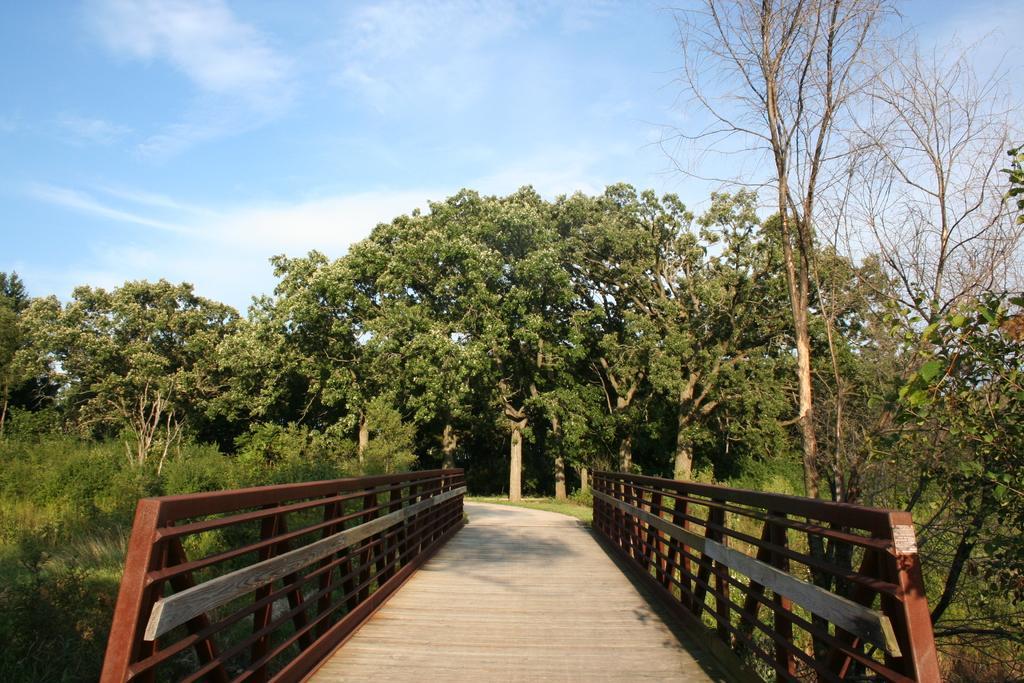Can you describe this image briefly? In this image in the front there is a bridge, on the bridge there are railings. On the left side there are plants and in the background there are trees and the sky is cloudy. 